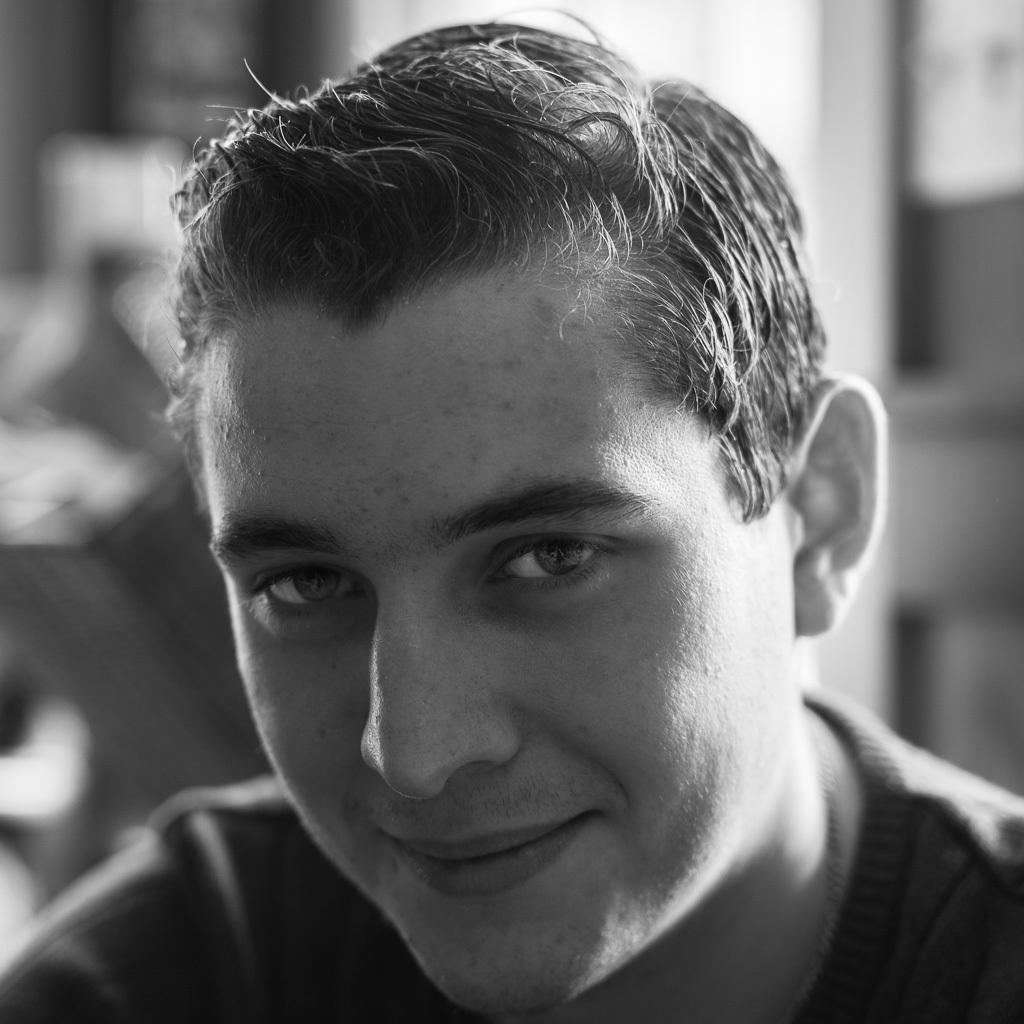Describe this image in one or two sentences. In the center of the image we can see a man smiling. 